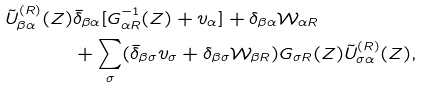<formula> <loc_0><loc_0><loc_500><loc_500>\tilde { U } ^ { ( R ) } _ { \beta \alpha } ( Z ) & \bar { \delta } _ { \beta \alpha } [ G _ { \alpha R } ^ { - 1 } ( Z ) + v _ { \alpha } ] + { \delta } _ { \beta \alpha } \mathcal { W } _ { \alpha R } \\ & + \sum _ { \sigma } ( \bar { \delta } _ { \beta \sigma } v _ { \sigma } + { \delta } _ { \beta \sigma } \mathcal { W } _ { \beta R } ) G _ { \sigma R } ( Z ) \tilde { U } ^ { ( R ) } _ { \sigma \alpha } ( Z ) ,</formula> 